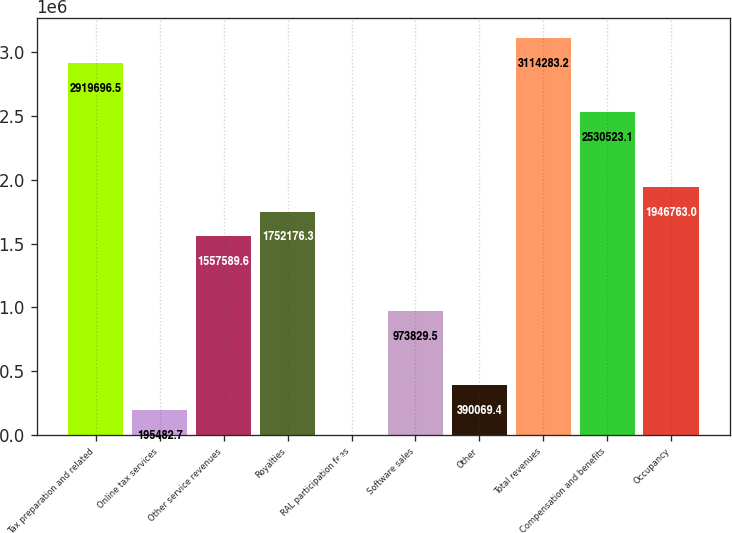<chart> <loc_0><loc_0><loc_500><loc_500><bar_chart><fcel>Tax preparation and related<fcel>Online tax services<fcel>Other service revenues<fcel>Royalties<fcel>RAL participation fees<fcel>Software sales<fcel>Other<fcel>Total revenues<fcel>Compensation and benefits<fcel>Occupancy<nl><fcel>2.9197e+06<fcel>195483<fcel>1.55759e+06<fcel>1.75218e+06<fcel>896<fcel>973830<fcel>390069<fcel>3.11428e+06<fcel>2.53052e+06<fcel>1.94676e+06<nl></chart> 